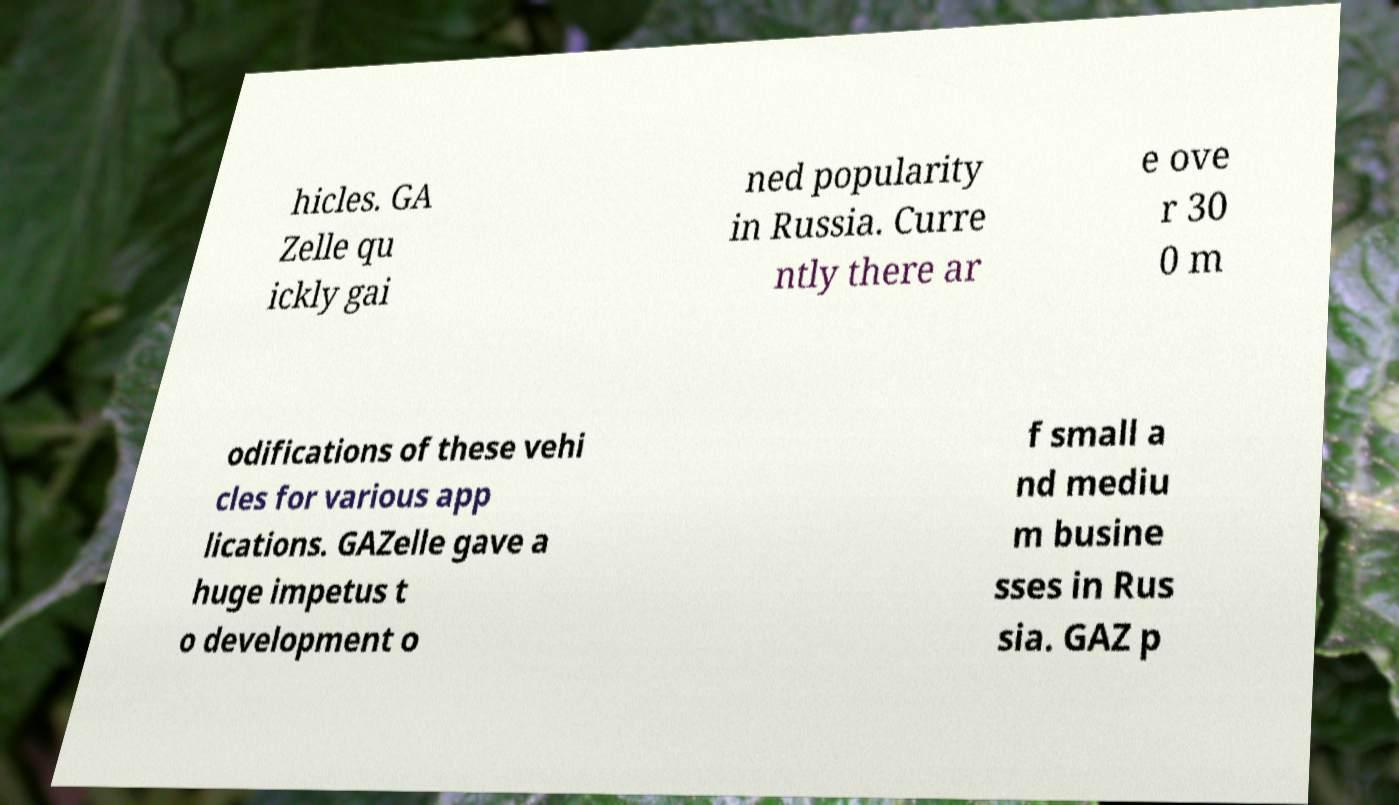There's text embedded in this image that I need extracted. Can you transcribe it verbatim? hicles. GA Zelle qu ickly gai ned popularity in Russia. Curre ntly there ar e ove r 30 0 m odifications of these vehi cles for various app lications. GAZelle gave a huge impetus t o development o f small a nd mediu m busine sses in Rus sia. GAZ p 